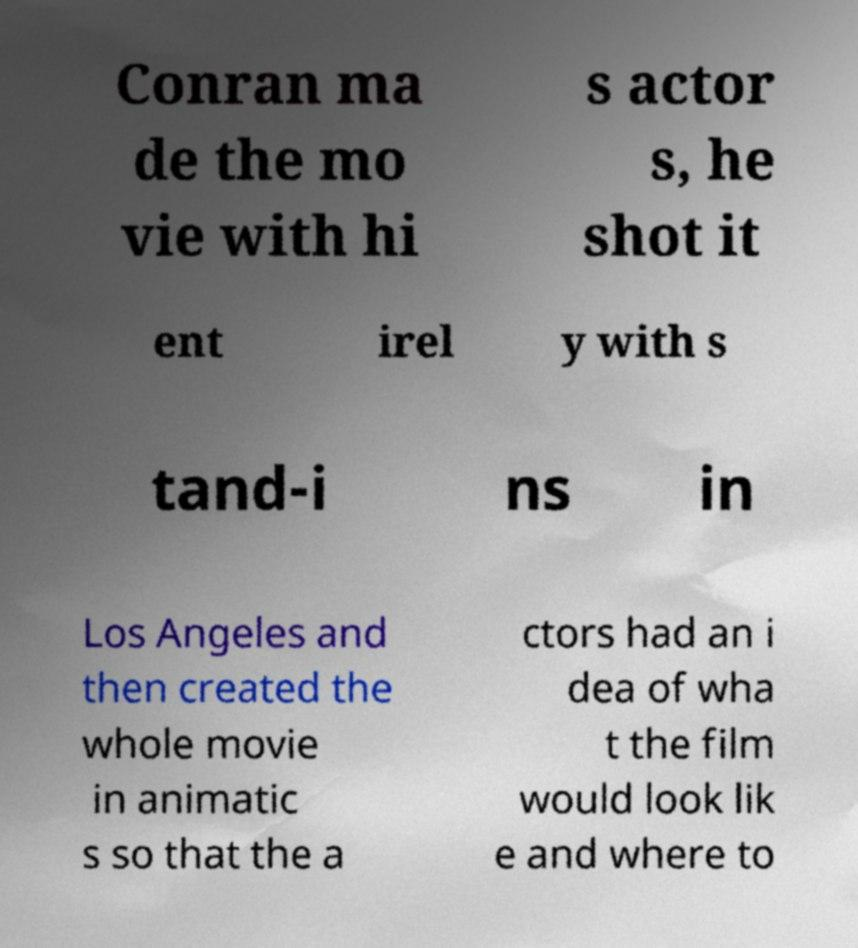For documentation purposes, I need the text within this image transcribed. Could you provide that? Conran ma de the mo vie with hi s actor s, he shot it ent irel y with s tand-i ns in Los Angeles and then created the whole movie in animatic s so that the a ctors had an i dea of wha t the film would look lik e and where to 